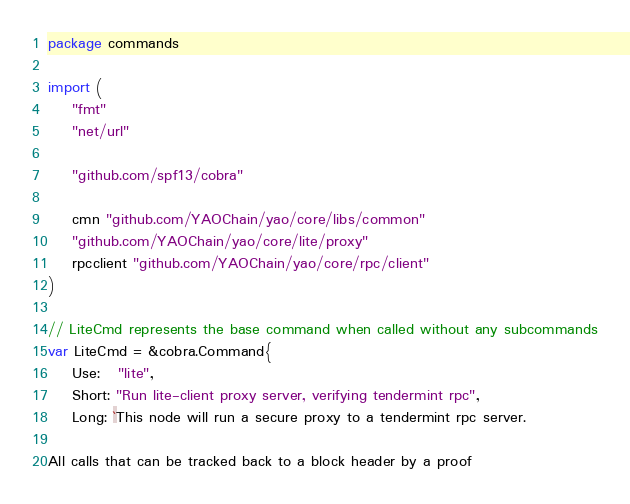<code> <loc_0><loc_0><loc_500><loc_500><_Go_>package commands

import (
	"fmt"
	"net/url"

	"github.com/spf13/cobra"

	cmn "github.com/YAOChain/yao/core/libs/common"
	"github.com/YAOChain/yao/core/lite/proxy"
	rpcclient "github.com/YAOChain/yao/core/rpc/client"
)

// LiteCmd represents the base command when called without any subcommands
var LiteCmd = &cobra.Command{
	Use:   "lite",
	Short: "Run lite-client proxy server, verifying tendermint rpc",
	Long: `This node will run a secure proxy to a tendermint rpc server.

All calls that can be tracked back to a block header by a proof</code> 